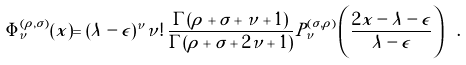Convert formula to latex. <formula><loc_0><loc_0><loc_500><loc_500>\Phi ^ { ( \rho , \sigma ) } _ { \nu } ( x ) = ( \lambda - \epsilon ) ^ { \nu } \nu ! \, \frac { \Gamma ( \rho + \sigma + \nu + 1 ) } { \Gamma ( \rho + \sigma + 2 \nu + 1 ) } P ^ { ( \sigma , \rho ) } _ { \nu } \left ( \frac { 2 x - \lambda - \epsilon } { \lambda - \epsilon } \right ) \ .</formula> 